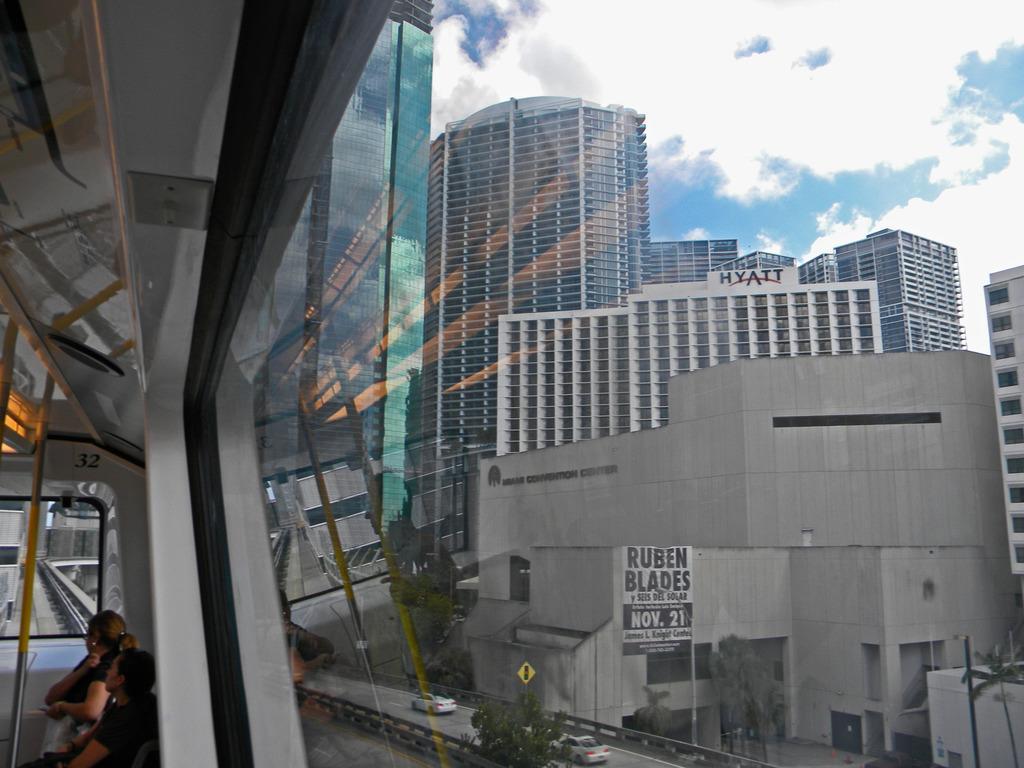How would you summarize this image in a sentence or two? In front of the image there is a glass window of a metro train, through the glass we can see vehicles on the roads and there are sign boards, lamp posts, trees and buildings. On the buildings there are name boards and banners. On the left side of the image there are two people sitting in chairs in the metro, in front of them there is a metal rod, through the glass we can see the track. At the top of the image there are clouds in the sky.  